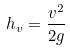Convert formula to latex. <formula><loc_0><loc_0><loc_500><loc_500>h _ { v } = \frac { v ^ { 2 } } { 2 g }</formula> 